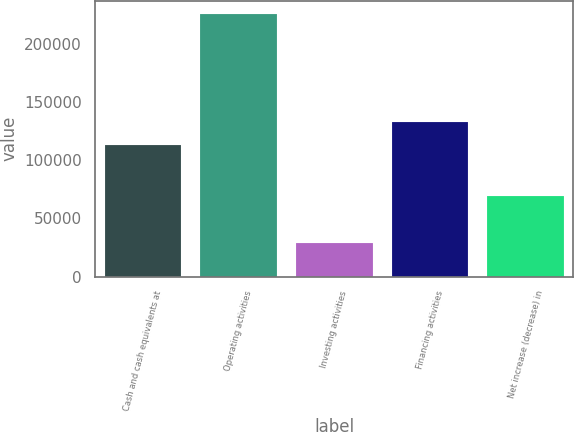Convert chart to OTSL. <chart><loc_0><loc_0><loc_500><loc_500><bar_chart><fcel>Cash and cash equivalents at<fcel>Operating activities<fcel>Investing activities<fcel>Financing activities<fcel>Net increase (decrease) in<nl><fcel>113159<fcel>225639<fcel>28873<fcel>133186<fcel>69255.6<nl></chart> 